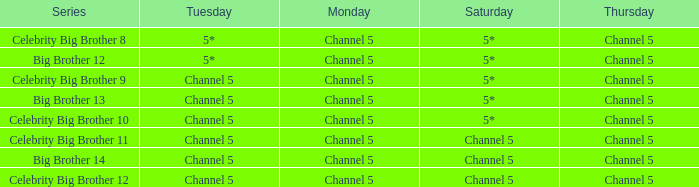Which Tuesday does big brother 12 air? 5*. 